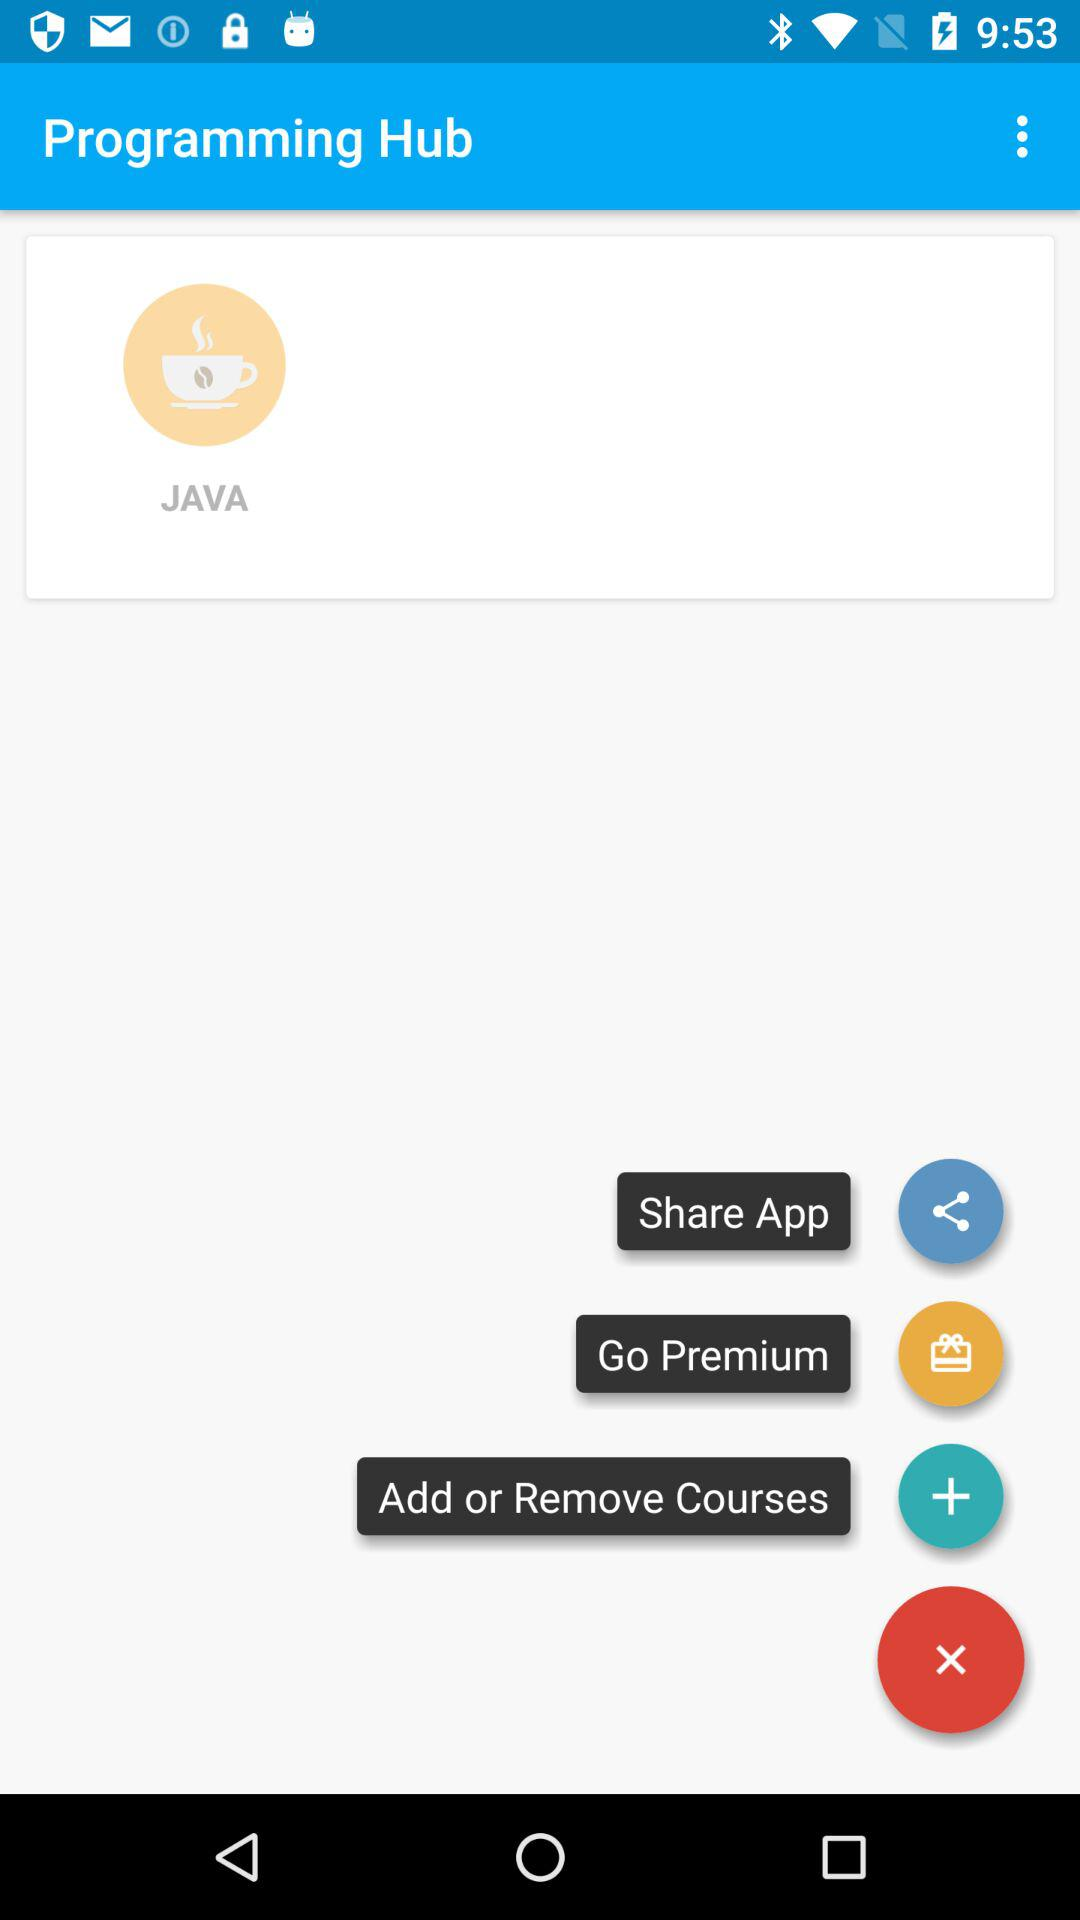What is the name of the application? The name of application is "Programming Hub". 